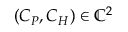Convert formula to latex. <formula><loc_0><loc_0><loc_500><loc_500>( C _ { P } , C _ { H } ) \in \mathbb { C } ^ { 2 }</formula> 